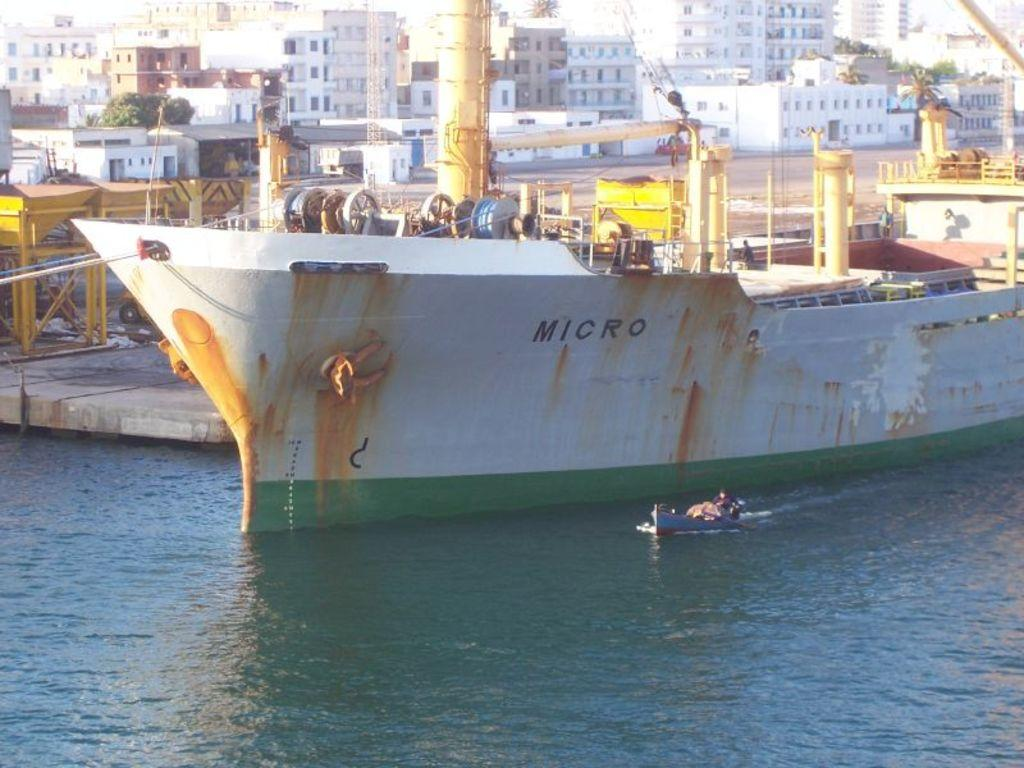What is in the water in the image? There are boats in the water in the image. What can be seen in the background of the image? There are buildings, trees, and poles in the background of the image. What type of wax is being used to create the scene in the image? There is no wax present in the image, and the scene is not being created with wax. 